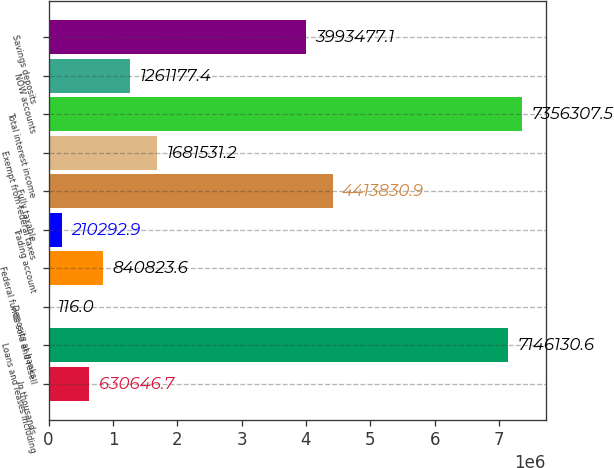Convert chart. <chart><loc_0><loc_0><loc_500><loc_500><bar_chart><fcel>In thousands<fcel>Loans and leases including<fcel>Deposits at banks<fcel>Federal funds sold and resell<fcel>Trading account<fcel>Fully taxable<fcel>Exempt from federal taxes<fcel>Total interest income<fcel>NOW accounts<fcel>Savings deposits<nl><fcel>630647<fcel>7.14613e+06<fcel>116<fcel>840824<fcel>210293<fcel>4.41383e+06<fcel>1.68153e+06<fcel>7.35631e+06<fcel>1.26118e+06<fcel>3.99348e+06<nl></chart> 